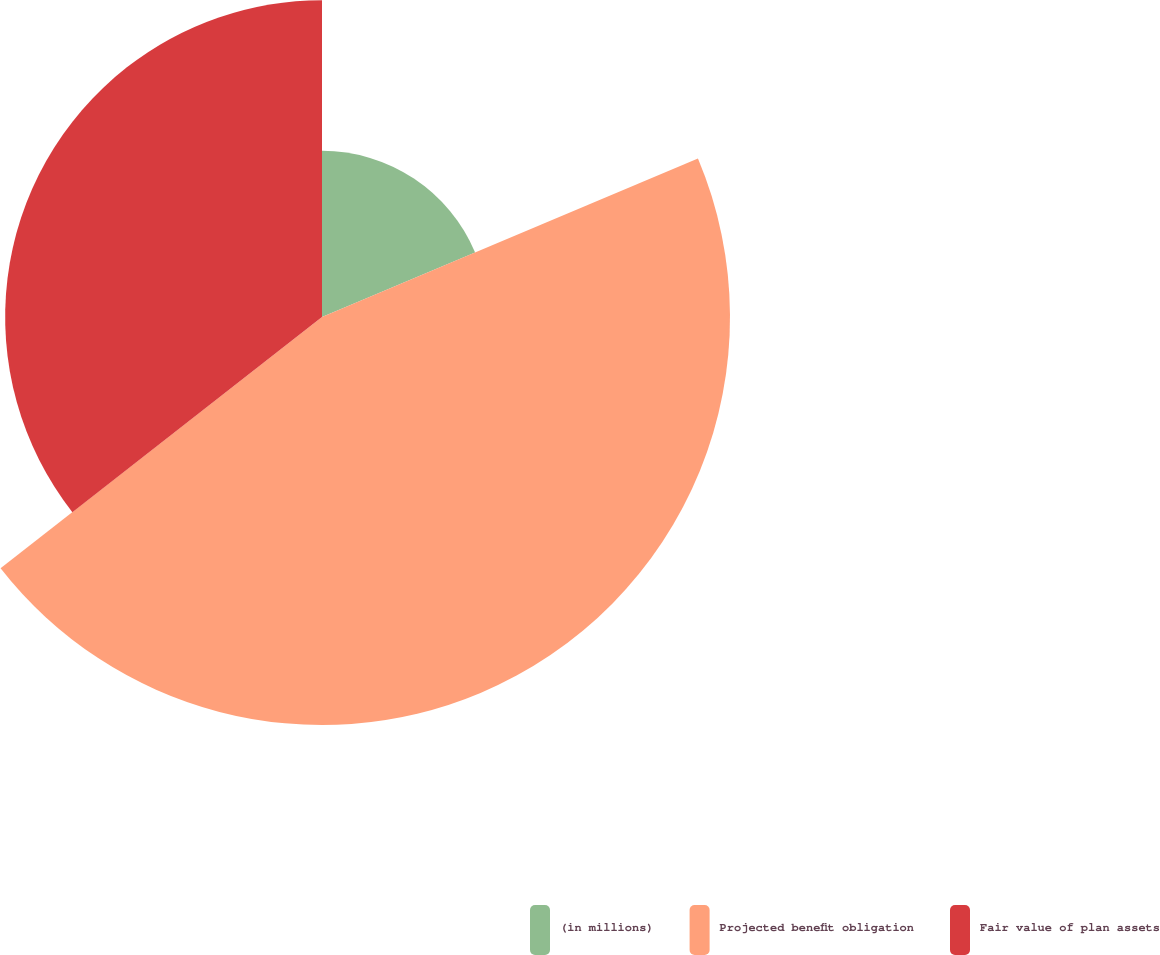Convert chart. <chart><loc_0><loc_0><loc_500><loc_500><pie_chart><fcel>(in millions)<fcel>Projected benefit obligation<fcel>Fair value of plan assets<nl><fcel>18.65%<fcel>45.79%<fcel>35.56%<nl></chart> 